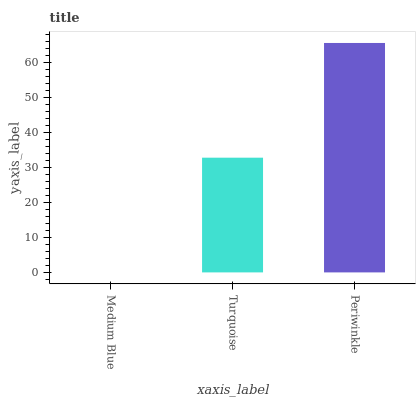Is Turquoise the minimum?
Answer yes or no. No. Is Turquoise the maximum?
Answer yes or no. No. Is Turquoise greater than Medium Blue?
Answer yes or no. Yes. Is Medium Blue less than Turquoise?
Answer yes or no. Yes. Is Medium Blue greater than Turquoise?
Answer yes or no. No. Is Turquoise less than Medium Blue?
Answer yes or no. No. Is Turquoise the high median?
Answer yes or no. Yes. Is Turquoise the low median?
Answer yes or no. Yes. Is Medium Blue the high median?
Answer yes or no. No. Is Periwinkle the low median?
Answer yes or no. No. 